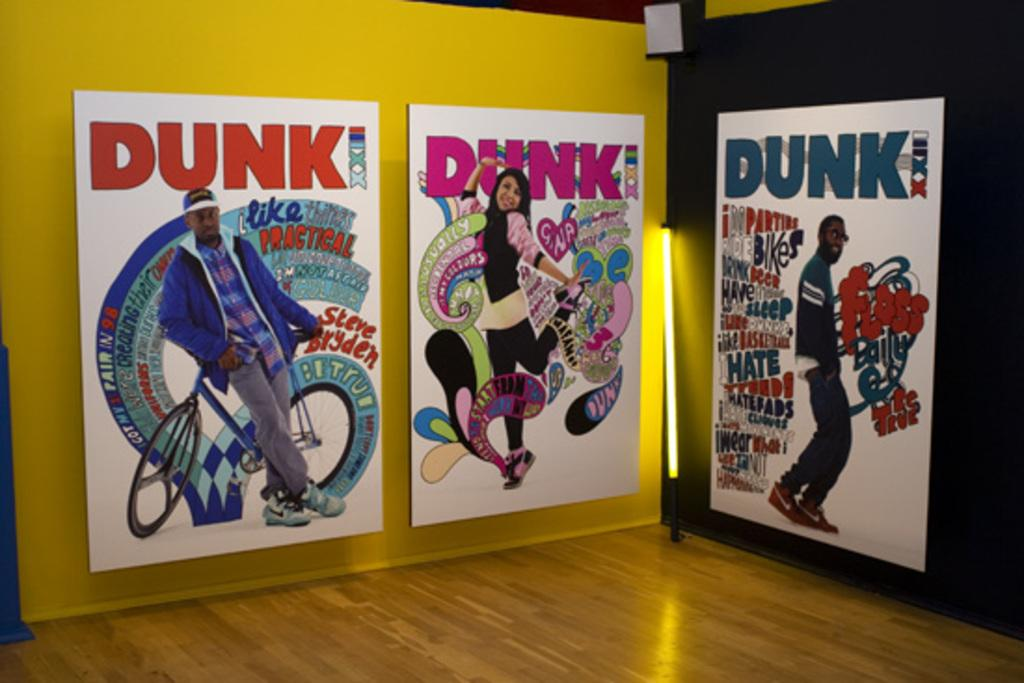<image>
Render a clear and concise summary of the photo. Posters on a wall that says DUNK with 2 men and a woman on them. 